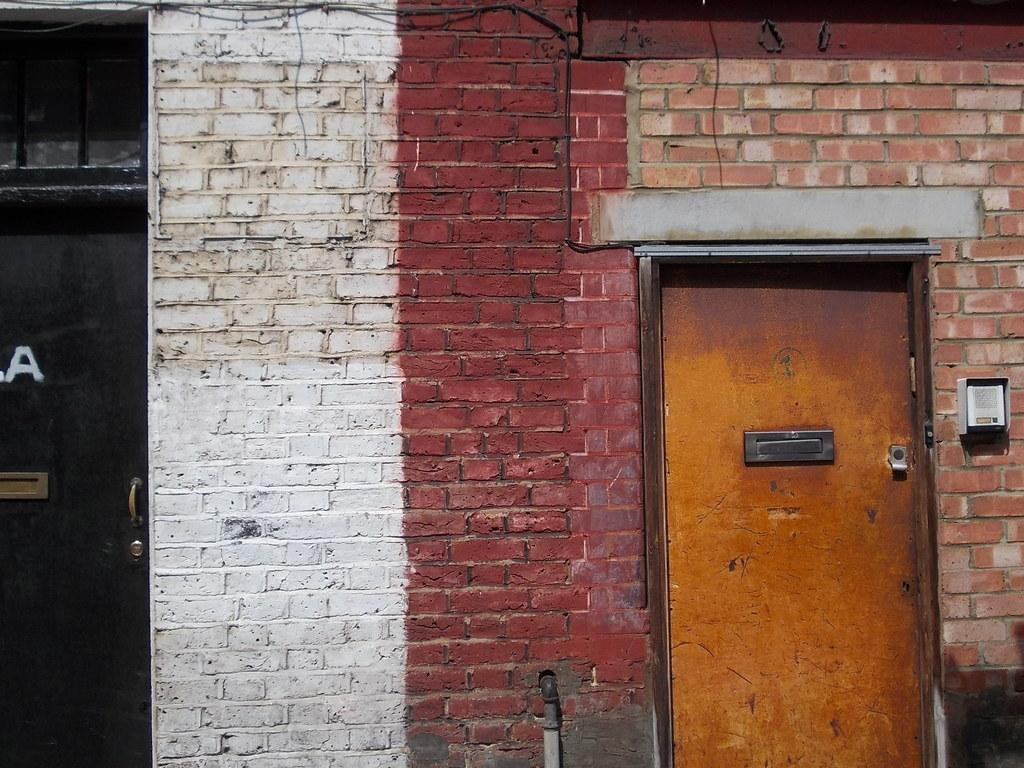What type of structure is visible in the image? There is a brick wall in the image. Is there any entrance visible in the image? Yes, there is a door in front of the wall. Can you describe the door on the left side of the image? There is a black door on the left side of the image. How many soldiers are present in the image? There are no soldiers or army members present in the image; it features a brick wall and a door. What type of gardening tool can be seen in the image? There is no gardening tool, such as a rake, present in the image. 